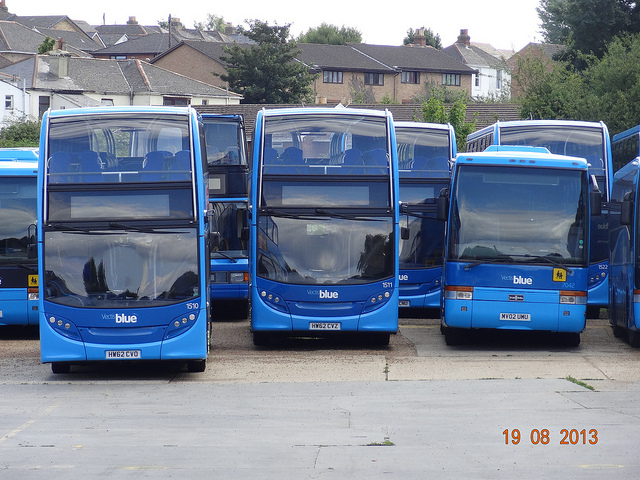Please identify all text content in this image. BLUE blue blue 2013 08 19 HMGZ 